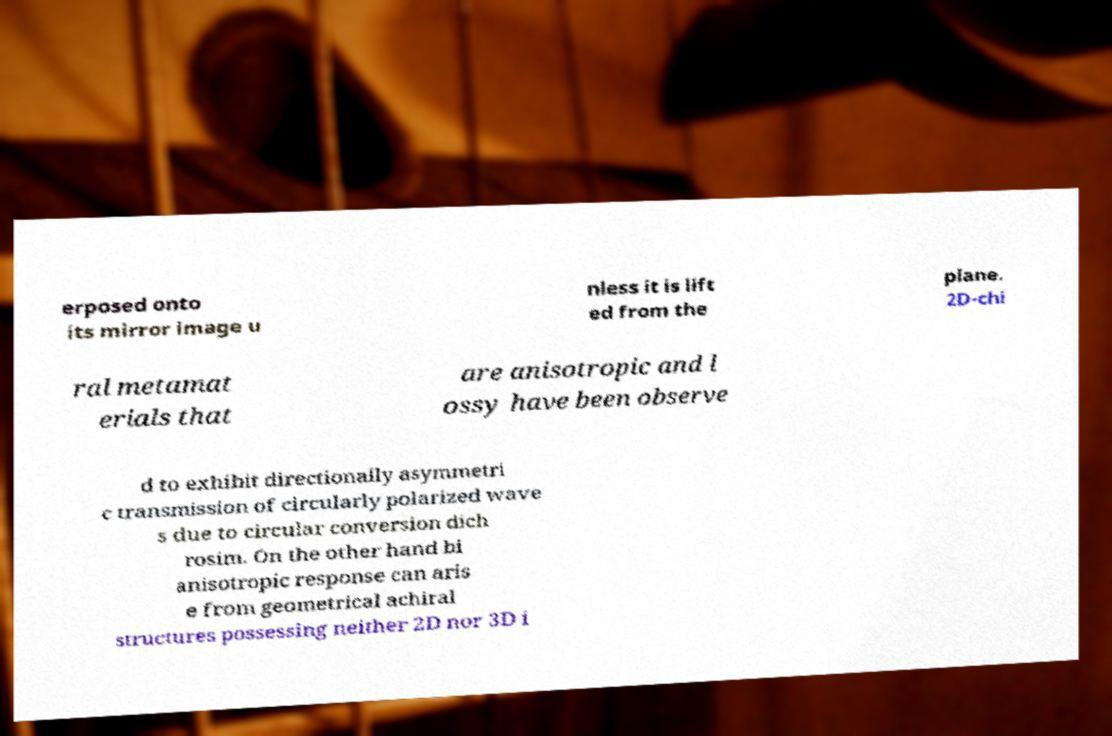Please read and relay the text visible in this image. What does it say? erposed onto its mirror image u nless it is lift ed from the plane. 2D-chi ral metamat erials that are anisotropic and l ossy have been observe d to exhibit directionally asymmetri c transmission of circularly polarized wave s due to circular conversion dich rosim. On the other hand bi anisotropic response can aris e from geometrical achiral structures possessing neither 2D nor 3D i 